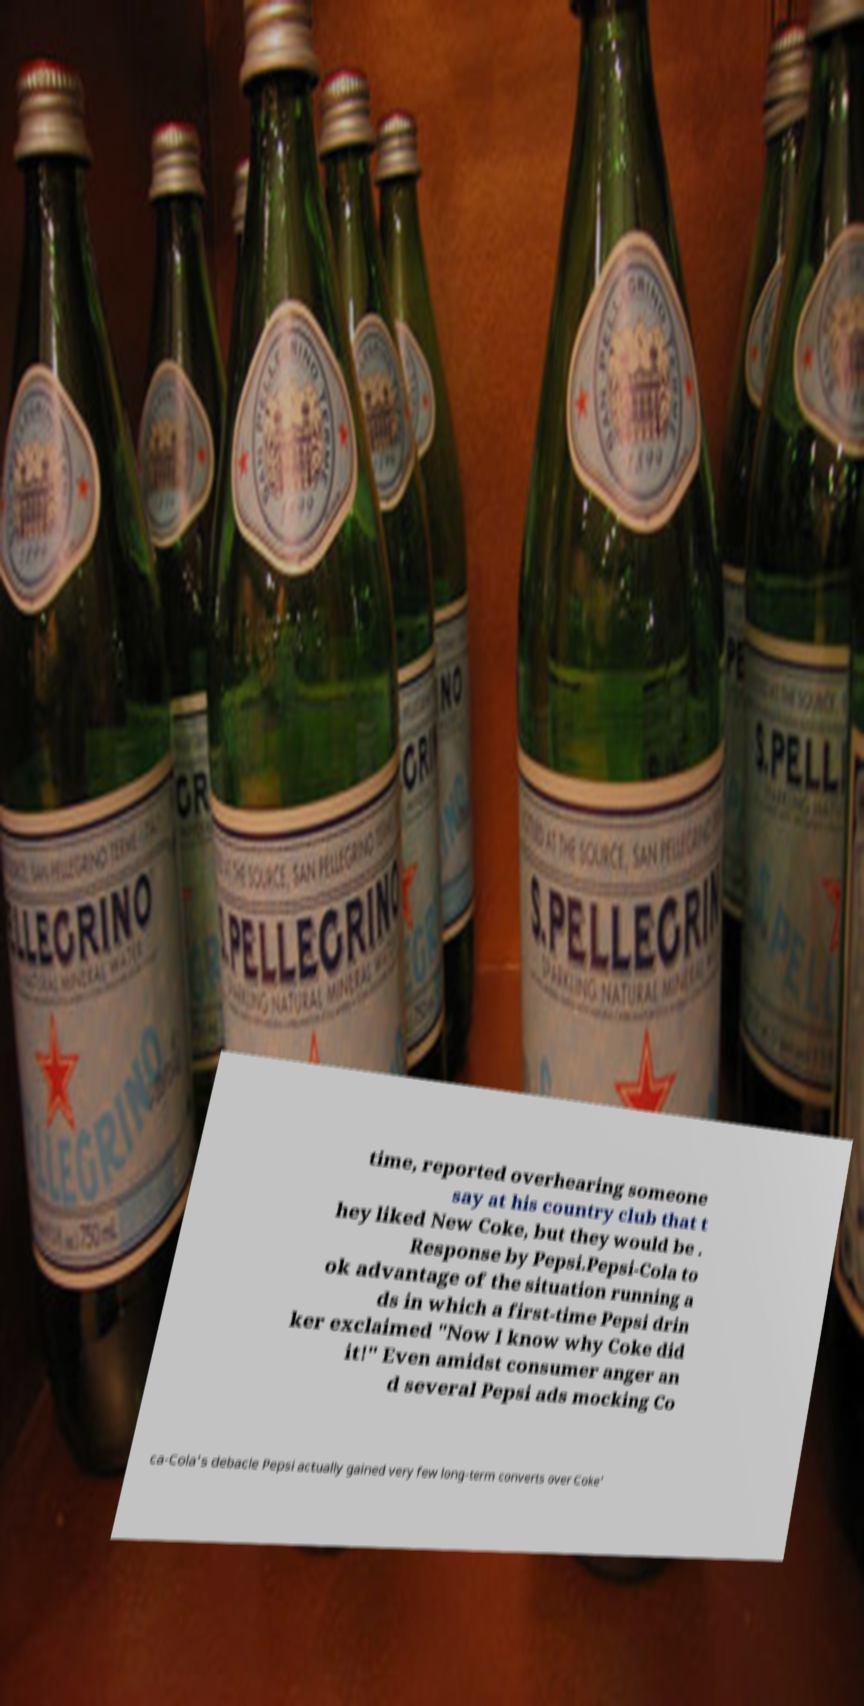For documentation purposes, I need the text within this image transcribed. Could you provide that? time, reported overhearing someone say at his country club that t hey liked New Coke, but they would be . Response by Pepsi.Pepsi-Cola to ok advantage of the situation running a ds in which a first-time Pepsi drin ker exclaimed "Now I know why Coke did it!" Even amidst consumer anger an d several Pepsi ads mocking Co ca-Cola's debacle Pepsi actually gained very few long-term converts over Coke' 